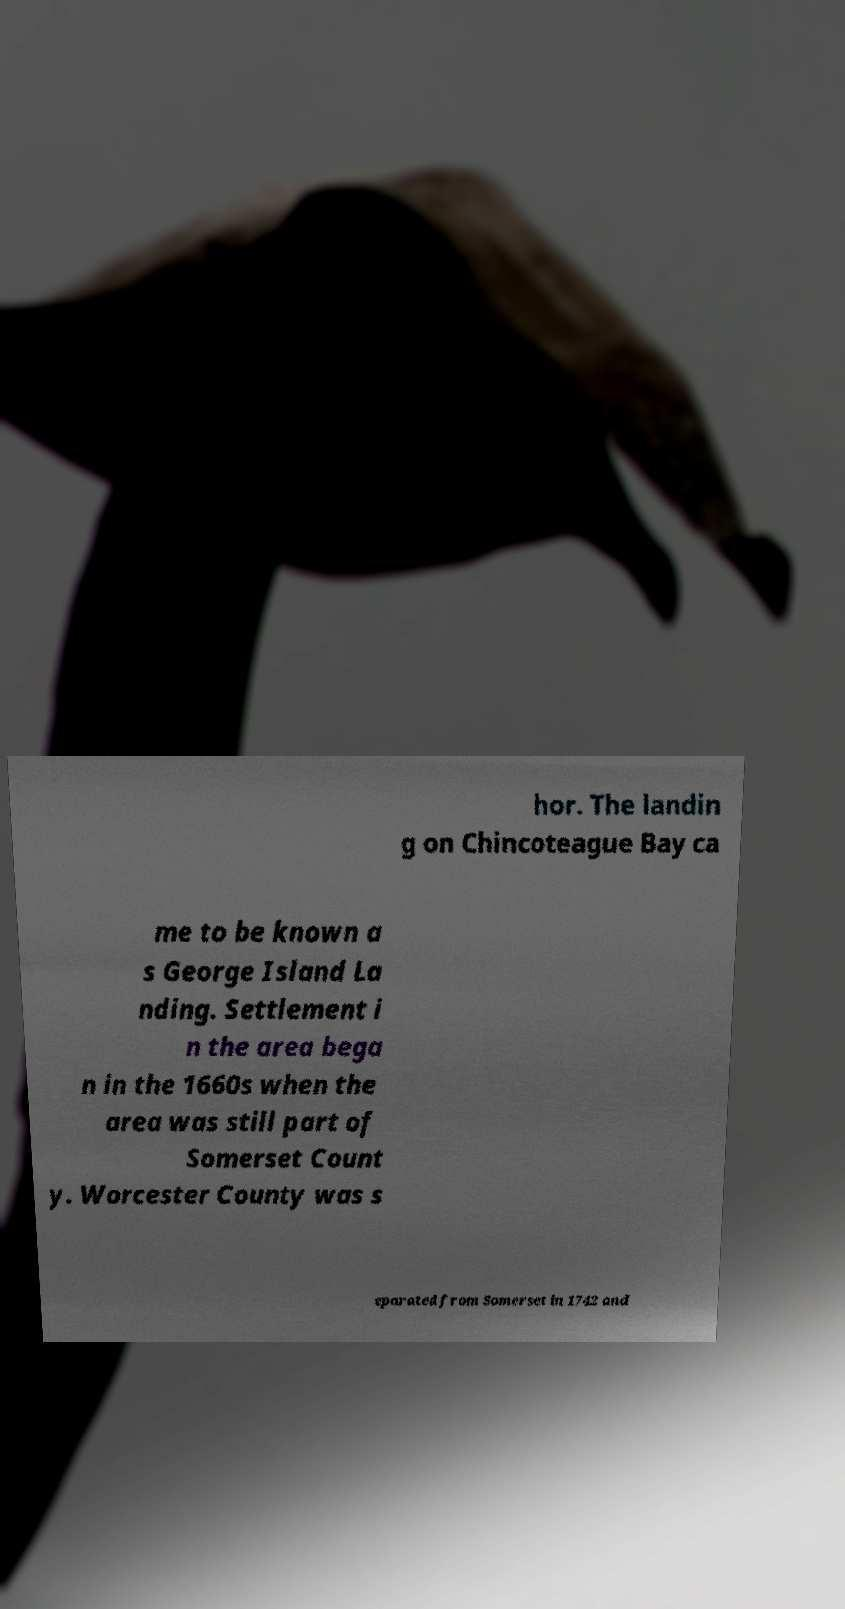I need the written content from this picture converted into text. Can you do that? hor. The landin g on Chincoteague Bay ca me to be known a s George Island La nding. Settlement i n the area bega n in the 1660s when the area was still part of Somerset Count y. Worcester County was s eparated from Somerset in 1742 and 